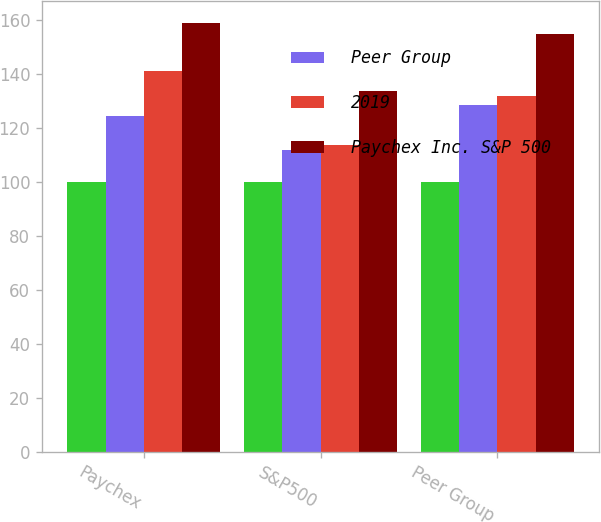Convert chart to OTSL. <chart><loc_0><loc_0><loc_500><loc_500><stacked_bar_chart><ecel><fcel>Paychex<fcel>S&P500<fcel>Peer Group<nl><fcel>nan<fcel>100<fcel>100<fcel>100<nl><fcel>Peer Group<fcel>124.25<fcel>111.81<fcel>128.44<nl><fcel>2019<fcel>141.11<fcel>113.72<fcel>131.81<nl><fcel>Paychex Inc. S&P 500<fcel>159.07<fcel>133.59<fcel>154.93<nl></chart> 